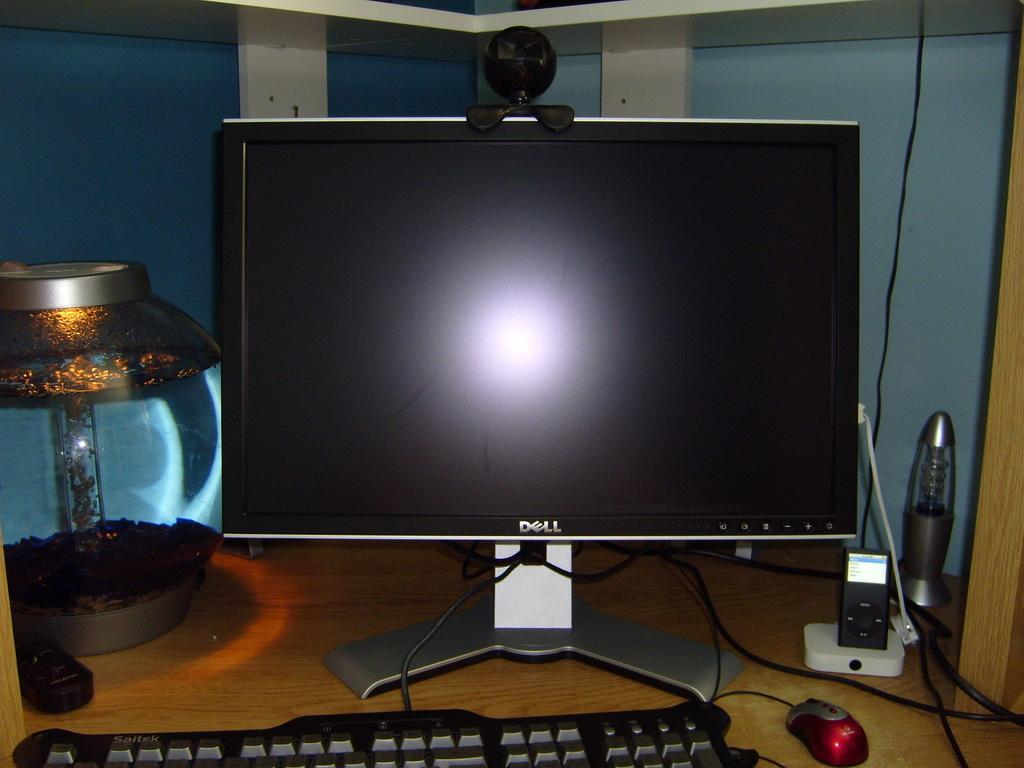Provide a one-sentence caption for the provided image. Dell computer monitor with a reflection sitting on a desk with light keyboard and mouse. 